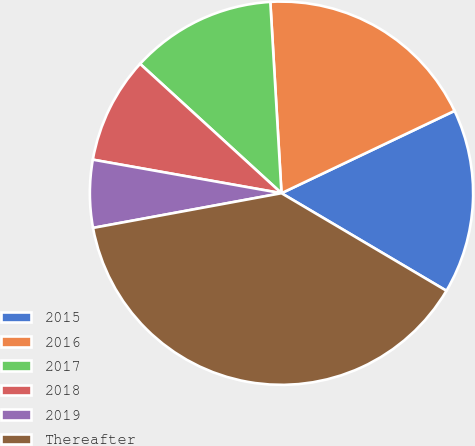Convert chart. <chart><loc_0><loc_0><loc_500><loc_500><pie_chart><fcel>2015<fcel>2016<fcel>2017<fcel>2018<fcel>2019<fcel>Thereafter<nl><fcel>15.57%<fcel>18.86%<fcel>12.28%<fcel>8.99%<fcel>5.7%<fcel>38.6%<nl></chart> 